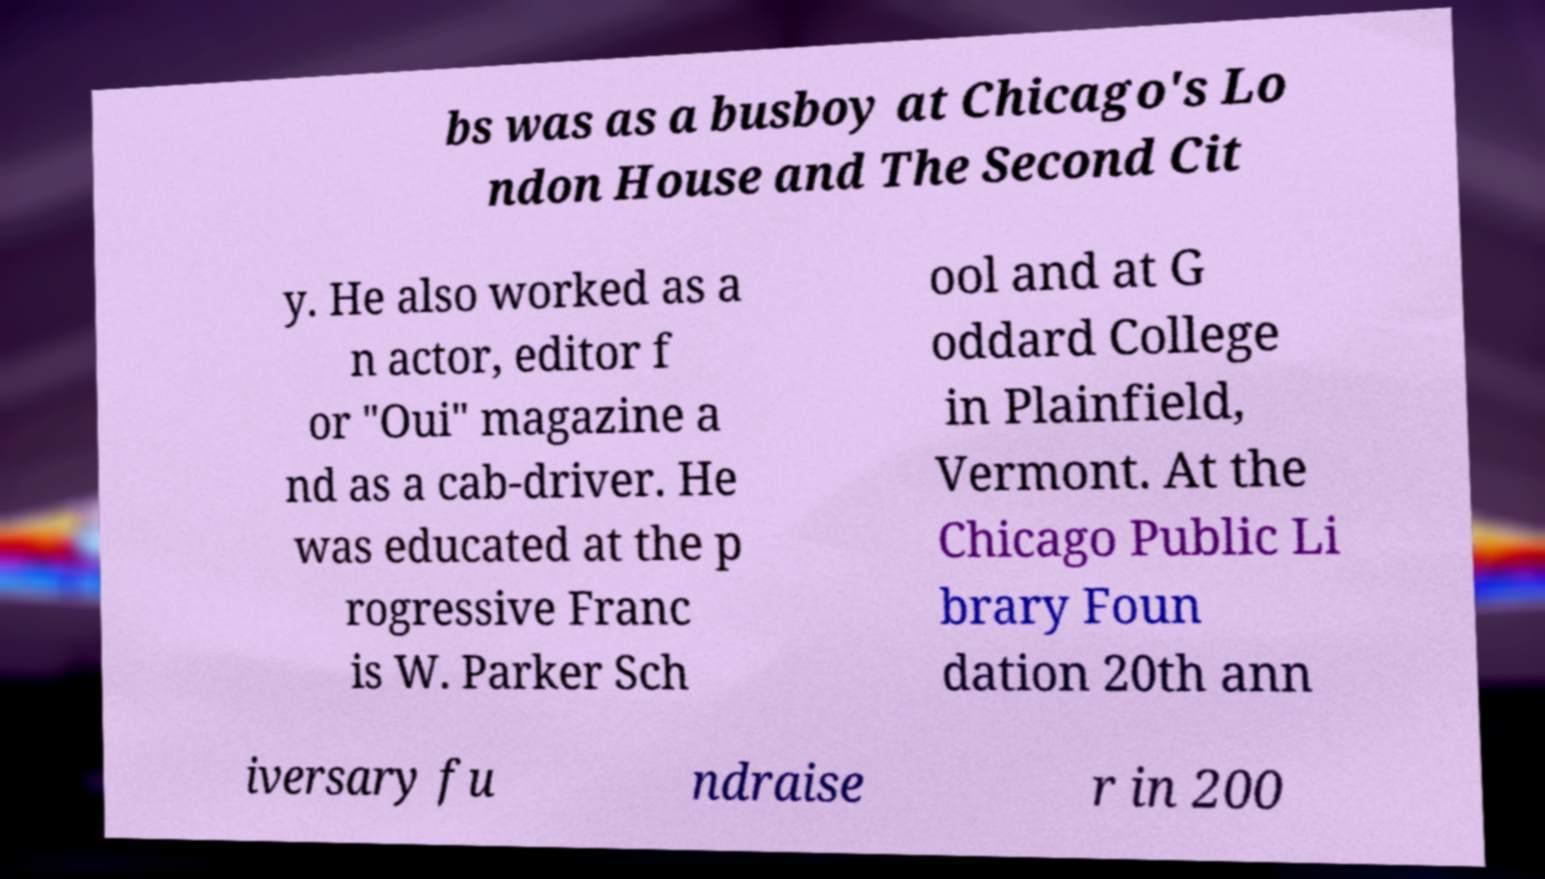Could you extract and type out the text from this image? bs was as a busboy at Chicago's Lo ndon House and The Second Cit y. He also worked as a n actor, editor f or "Oui" magazine a nd as a cab-driver. He was educated at the p rogressive Franc is W. Parker Sch ool and at G oddard College in Plainfield, Vermont. At the Chicago Public Li brary Foun dation 20th ann iversary fu ndraise r in 200 